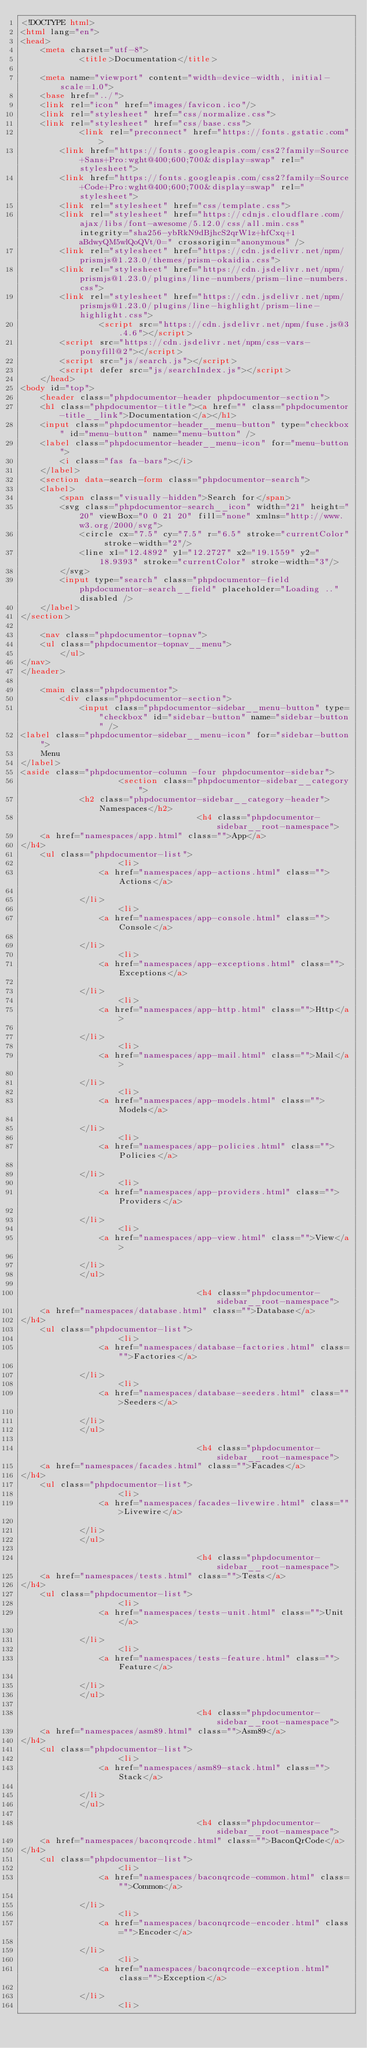<code> <loc_0><loc_0><loc_500><loc_500><_HTML_><!DOCTYPE html>
<html lang="en">
<head>
    <meta charset="utf-8">
            <title>Documentation</title>
    
    <meta name="viewport" content="width=device-width, initial-scale=1.0">
    <base href="../">
    <link rel="icon" href="images/favicon.ico"/>
    <link rel="stylesheet" href="css/normalize.css">
    <link rel="stylesheet" href="css/base.css">
            <link rel="preconnect" href="https://fonts.gstatic.com">
        <link href="https://fonts.googleapis.com/css2?family=Source+Sans+Pro:wght@400;600;700&display=swap" rel="stylesheet">
        <link href="https://fonts.googleapis.com/css2?family=Source+Code+Pro:wght@400;600;700&display=swap" rel="stylesheet">
        <link rel="stylesheet" href="css/template.css">
        <link rel="stylesheet" href="https://cdnjs.cloudflare.com/ajax/libs/font-awesome/5.12.0/css/all.min.css" integrity="sha256-ybRkN9dBjhcS2qrW1z+hfCxq+1aBdwyQM5wlQoQVt/0=" crossorigin="anonymous" />
        <link rel="stylesheet" href="https://cdn.jsdelivr.net/npm/prismjs@1.23.0/themes/prism-okaidia.css">
        <link rel="stylesheet" href="https://cdn.jsdelivr.net/npm/prismjs@1.23.0/plugins/line-numbers/prism-line-numbers.css">
        <link rel="stylesheet" href="https://cdn.jsdelivr.net/npm/prismjs@1.23.0/plugins/line-highlight/prism-line-highlight.css">
                <script src="https://cdn.jsdelivr.net/npm/fuse.js@3.4.6"></script>
        <script src="https://cdn.jsdelivr.net/npm/css-vars-ponyfill@2"></script>
        <script src="js/search.js"></script>
        <script defer src="js/searchIndex.js"></script>
    </head>
<body id="top">
    <header class="phpdocumentor-header phpdocumentor-section">
    <h1 class="phpdocumentor-title"><a href="" class="phpdocumentor-title__link">Documentation</a></h1>
    <input class="phpdocumentor-header__menu-button" type="checkbox" id="menu-button" name="menu-button" />
    <label class="phpdocumentor-header__menu-icon" for="menu-button">
        <i class="fas fa-bars"></i>
    </label>
    <section data-search-form class="phpdocumentor-search">
    <label>
        <span class="visually-hidden">Search for</span>
        <svg class="phpdocumentor-search__icon" width="21" height="20" viewBox="0 0 21 20" fill="none" xmlns="http://www.w3.org/2000/svg">
            <circle cx="7.5" cy="7.5" r="6.5" stroke="currentColor" stroke-width="2"/>
            <line x1="12.4892" y1="12.2727" x2="19.1559" y2="18.9393" stroke="currentColor" stroke-width="3"/>
        </svg>
        <input type="search" class="phpdocumentor-field phpdocumentor-search__field" placeholder="Loading .." disabled />
    </label>
</section>

    <nav class="phpdocumentor-topnav">
    <ul class="phpdocumentor-topnav__menu">
        </ul>
</nav>
</header>

    <main class="phpdocumentor">
        <div class="phpdocumentor-section">
            <input class="phpdocumentor-sidebar__menu-button" type="checkbox" id="sidebar-button" name="sidebar-button" />
<label class="phpdocumentor-sidebar__menu-icon" for="sidebar-button">
    Menu
</label>
<aside class="phpdocumentor-column -four phpdocumentor-sidebar">
                    <section class="phpdocumentor-sidebar__category">
            <h2 class="phpdocumentor-sidebar__category-header">Namespaces</h2>
                                    <h4 class="phpdocumentor-sidebar__root-namespace">
    <a href="namespaces/app.html" class="">App</a>
</h4>
    <ul class="phpdocumentor-list">
                    <li>
                <a href="namespaces/app-actions.html" class="">Actions</a>
                
            </li>
                    <li>
                <a href="namespaces/app-console.html" class="">Console</a>
                
            </li>
                    <li>
                <a href="namespaces/app-exceptions.html" class="">Exceptions</a>
                
            </li>
                    <li>
                <a href="namespaces/app-http.html" class="">Http</a>
                
            </li>
                    <li>
                <a href="namespaces/app-mail.html" class="">Mail</a>
                
            </li>
                    <li>
                <a href="namespaces/app-models.html" class="">Models</a>
                
            </li>
                    <li>
                <a href="namespaces/app-policies.html" class="">Policies</a>
                
            </li>
                    <li>
                <a href="namespaces/app-providers.html" class="">Providers</a>
                
            </li>
                    <li>
                <a href="namespaces/app-view.html" class="">View</a>
                
            </li>
            </ul>

                                    <h4 class="phpdocumentor-sidebar__root-namespace">
    <a href="namespaces/database.html" class="">Database</a>
</h4>
    <ul class="phpdocumentor-list">
                    <li>
                <a href="namespaces/database-factories.html" class="">Factories</a>
                
            </li>
                    <li>
                <a href="namespaces/database-seeders.html" class="">Seeders</a>
                
            </li>
            </ul>

                                    <h4 class="phpdocumentor-sidebar__root-namespace">
    <a href="namespaces/facades.html" class="">Facades</a>
</h4>
    <ul class="phpdocumentor-list">
                    <li>
                <a href="namespaces/facades-livewire.html" class="">Livewire</a>
                
            </li>
            </ul>

                                    <h4 class="phpdocumentor-sidebar__root-namespace">
    <a href="namespaces/tests.html" class="">Tests</a>
</h4>
    <ul class="phpdocumentor-list">
                    <li>
                <a href="namespaces/tests-unit.html" class="">Unit</a>
                
            </li>
                    <li>
                <a href="namespaces/tests-feature.html" class="">Feature</a>
                
            </li>
            </ul>

                                    <h4 class="phpdocumentor-sidebar__root-namespace">
    <a href="namespaces/asm89.html" class="">Asm89</a>
</h4>
    <ul class="phpdocumentor-list">
                    <li>
                <a href="namespaces/asm89-stack.html" class="">Stack</a>
                
            </li>
            </ul>

                                    <h4 class="phpdocumentor-sidebar__root-namespace">
    <a href="namespaces/baconqrcode.html" class="">BaconQrCode</a>
</h4>
    <ul class="phpdocumentor-list">
                    <li>
                <a href="namespaces/baconqrcode-common.html" class="">Common</a>
                
            </li>
                    <li>
                <a href="namespaces/baconqrcode-encoder.html" class="">Encoder</a>
                
            </li>
                    <li>
                <a href="namespaces/baconqrcode-exception.html" class="">Exception</a>
                
            </li>
                    <li></code> 